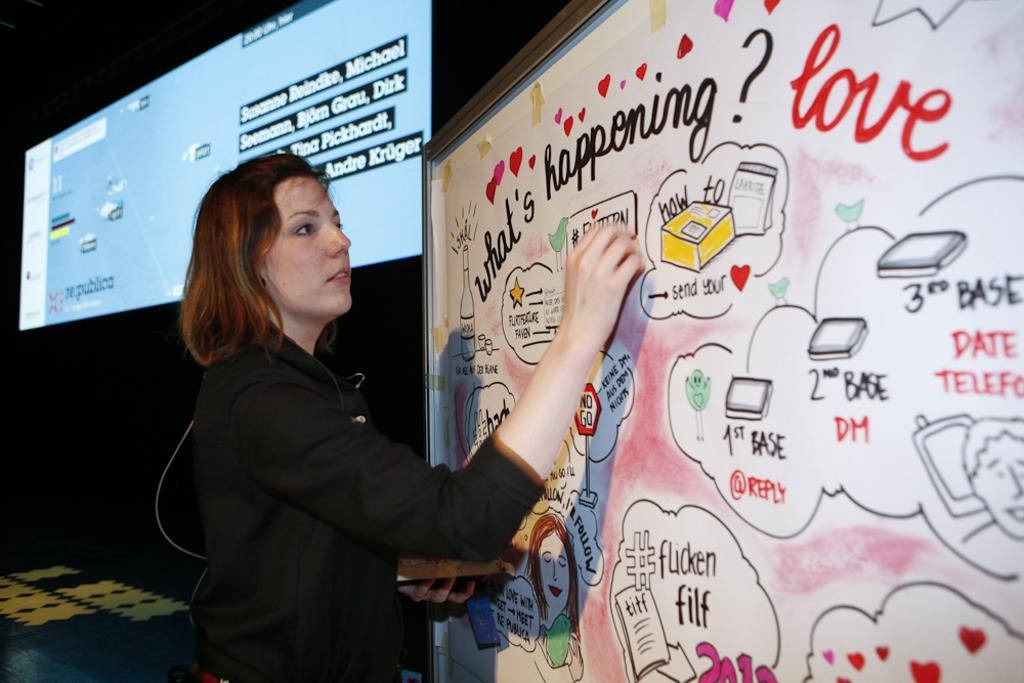<image>
Relay a brief, clear account of the picture shown. Someone drawimg on a white board with words and pictures showing the word love. 